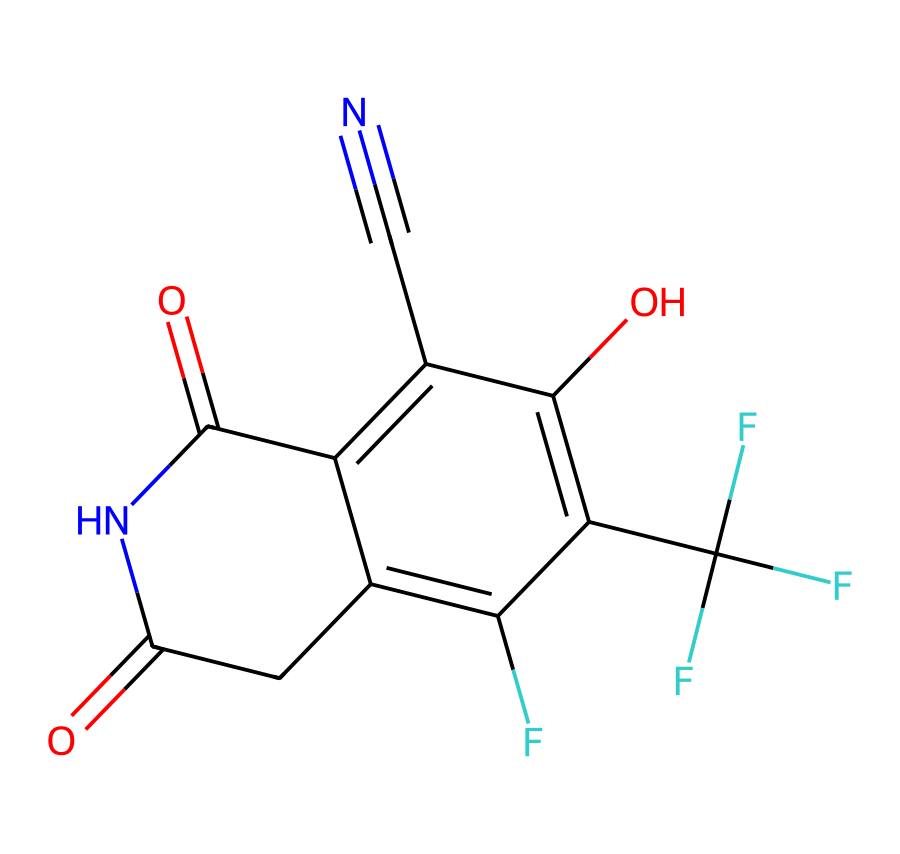What is the molecular formula of fludioxonil? To find the molecular formula, I can identify the types and numbers of atoms in the chemical structure. Counting from the SMILES: there are 12 carbon atoms (C), 8 hydrogen atoms (H), 4 fluorine atoms (F), 2 nitrogen atoms (N), and 3 oxygen atoms (O). Combining these counts gives the molecular formula as C12H8F4N2O3.
Answer: C12H8F4N2O3 How many rings are present in the structure of fludioxonil? Examining the connectivity in the SMILES representation, I can identify the core structure. The two distinct cyclized units indicate that the molecule contains two rings.
Answer: 2 What functional groups are present in fludioxonil? By analyzing the SMILES representation, I can recognize key functional groups. The structure contains amide (due to the carbonyl and nitrogen), hydroxyl (-OH), and aromatic groups. Therefore, I can summarize that fludioxonil has amide, hydroxyl, and aromatic functional groups.
Answer: amide, hydroxyl, aromatic What is the significance of the fluorine atoms in fludioxonil? The presence of fluorine atoms increases lipophilicity and stability in the chemical structure, which enhances the fungicidal activity of fludioxonil. This property allows better penetration into plant tissue and improves efficacy against fungi.
Answer: increases lipophilicity and stability How does the cyano group affect the fungicidal properties of fludioxonil? The cyano group, indicated by the C#N part, contributes to the molecular polarity and overall reactivity of fludioxonil. This high electronegativity can enhance binding interactions with fungal targets, thus improving its fungicidal effectiveness.
Answer: enhances binding interactions Which part of fludioxonil contributes to its selectivity against plant pathogens? The specific arrangement of the aromatic ring system coupled with the halogenated substituents contributes to the selectivity. The rigid structure helps fludioxonil interfere more effectively with specific biochemicals in fungi compared to non-target organisms.
Answer: aromatic ring system and halogen substituents 